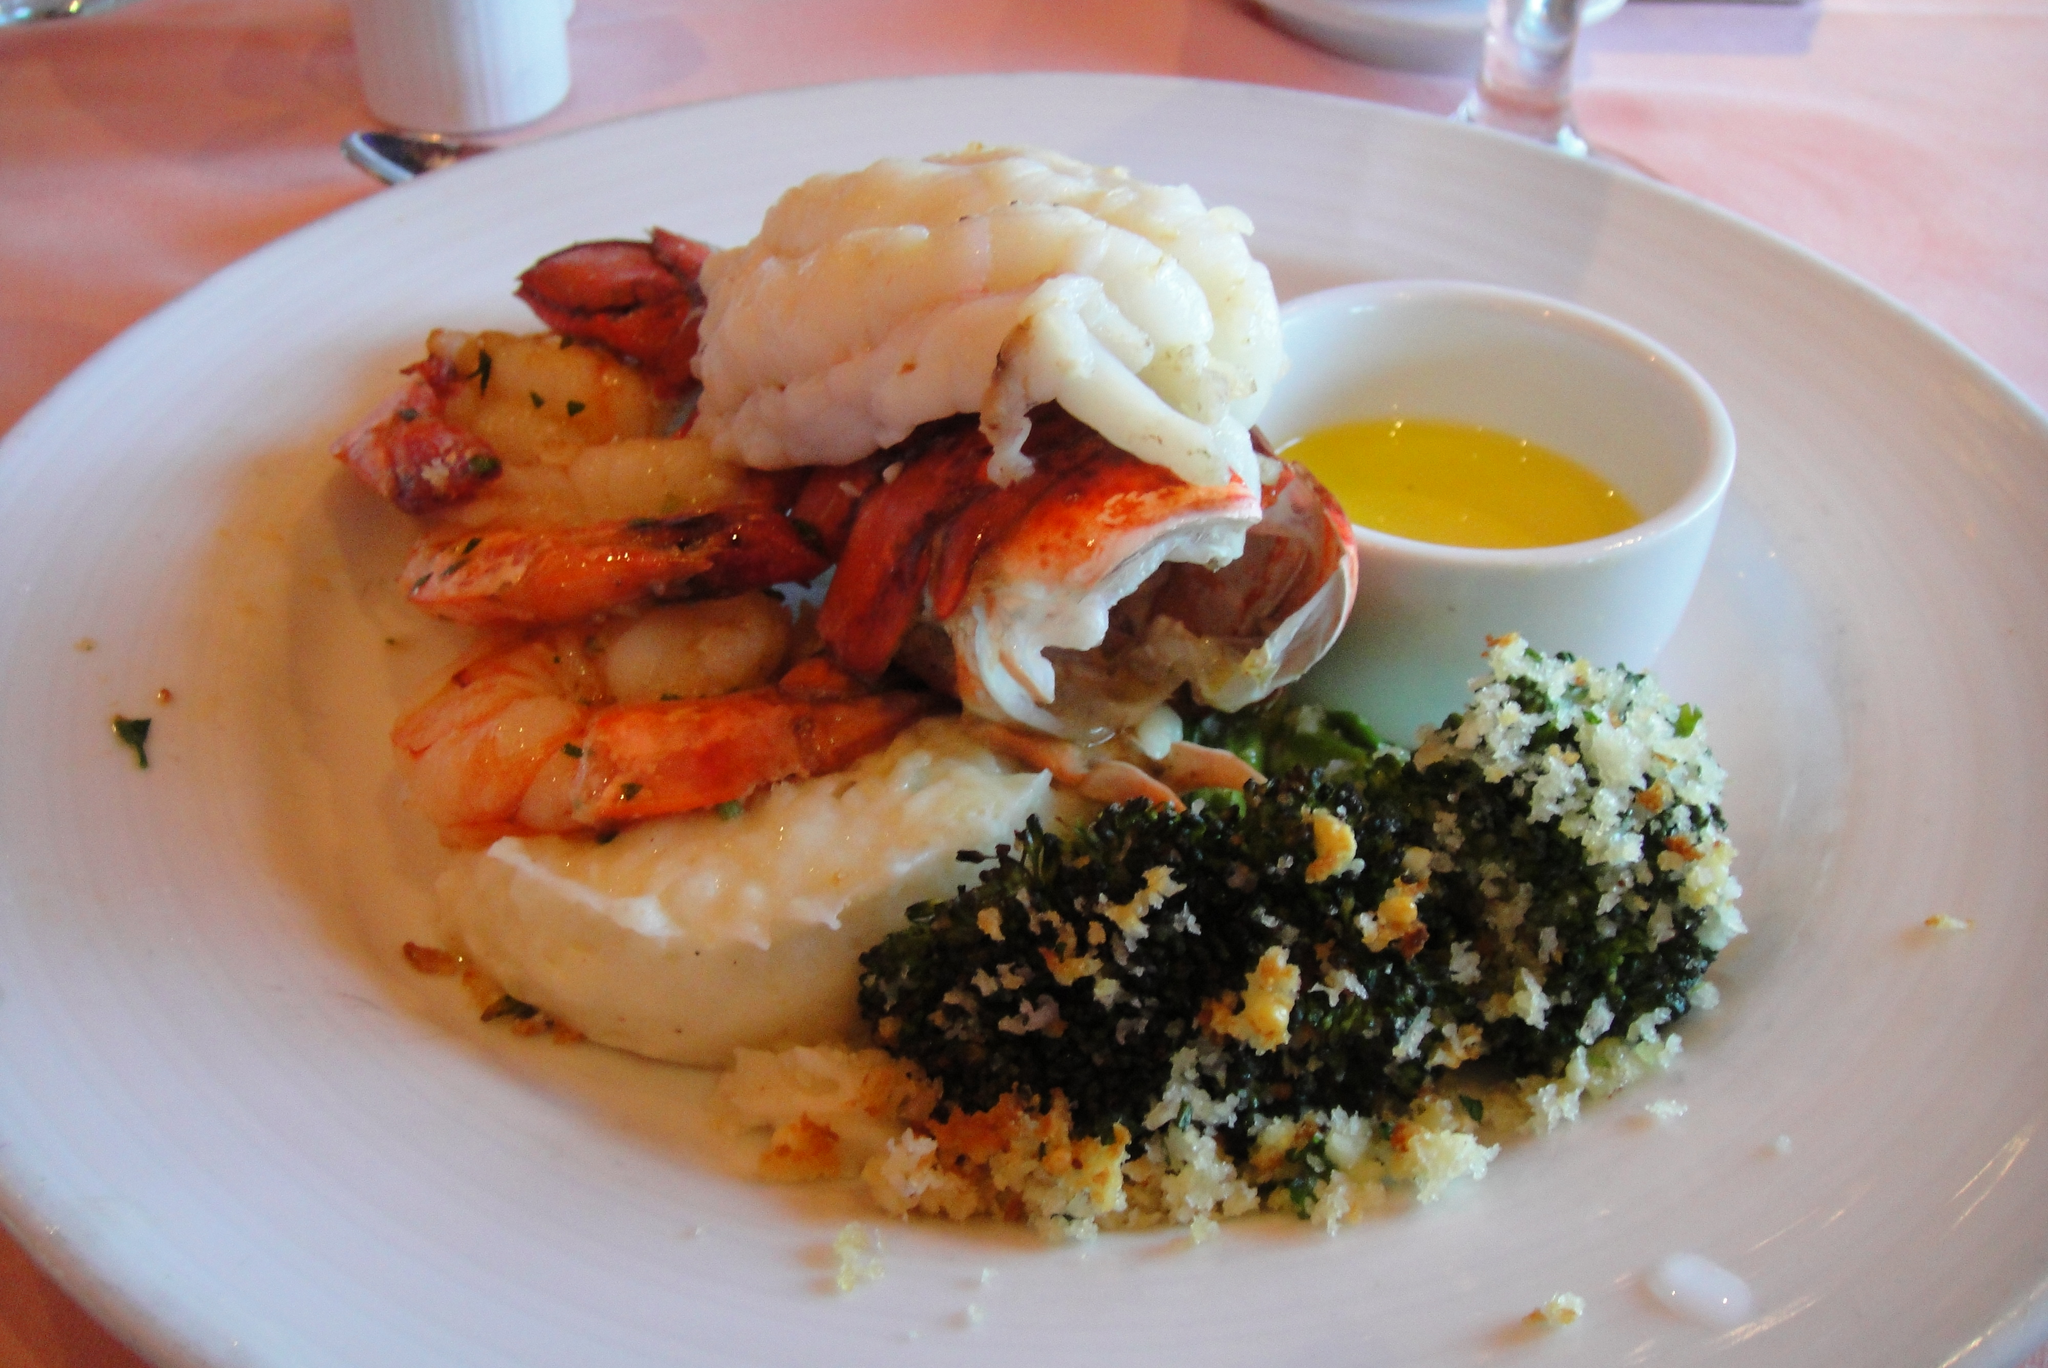How would you summarize this image in a sentence or two? In the picture we can see a white color plate on the table, on the plate we can see some food item and a bowl with some sauce which is yellow in color and beside the plate we can see a glass which is white in color and a part of the spoon. 